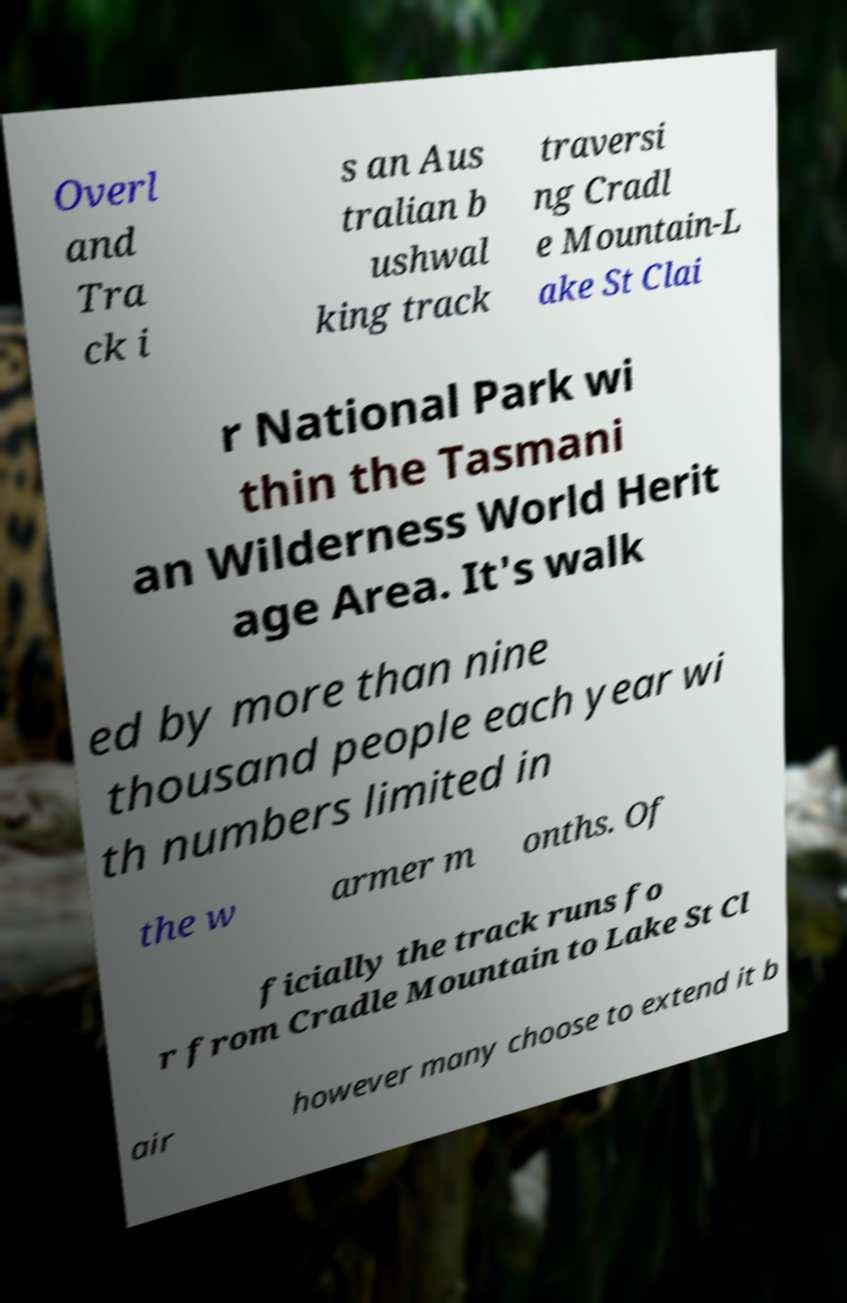Can you accurately transcribe the text from the provided image for me? Overl and Tra ck i s an Aus tralian b ushwal king track traversi ng Cradl e Mountain-L ake St Clai r National Park wi thin the Tasmani an Wilderness World Herit age Area. It's walk ed by more than nine thousand people each year wi th numbers limited in the w armer m onths. Of ficially the track runs fo r from Cradle Mountain to Lake St Cl air however many choose to extend it b 